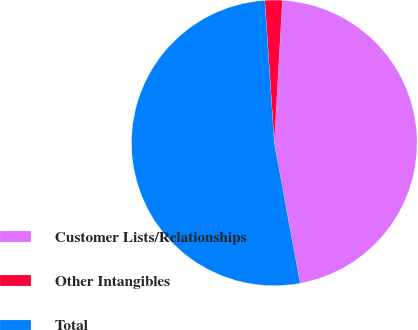Convert chart. <chart><loc_0><loc_0><loc_500><loc_500><pie_chart><fcel>Customer Lists/Relationships<fcel>Other Intangibles<fcel>Total<nl><fcel>46.2%<fcel>1.97%<fcel>51.83%<nl></chart> 